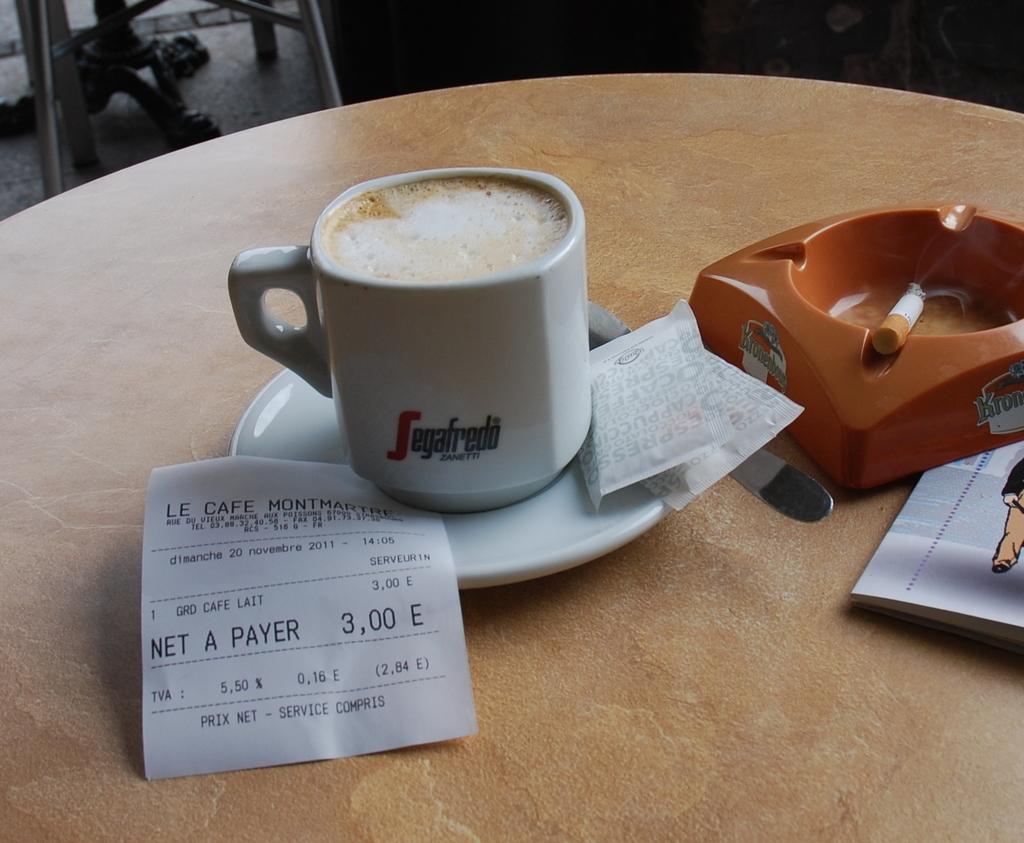Isthat a payment receipt?
Your response must be concise. Yes. Name this cafe?
Make the answer very short. Le cafe montmartre. 